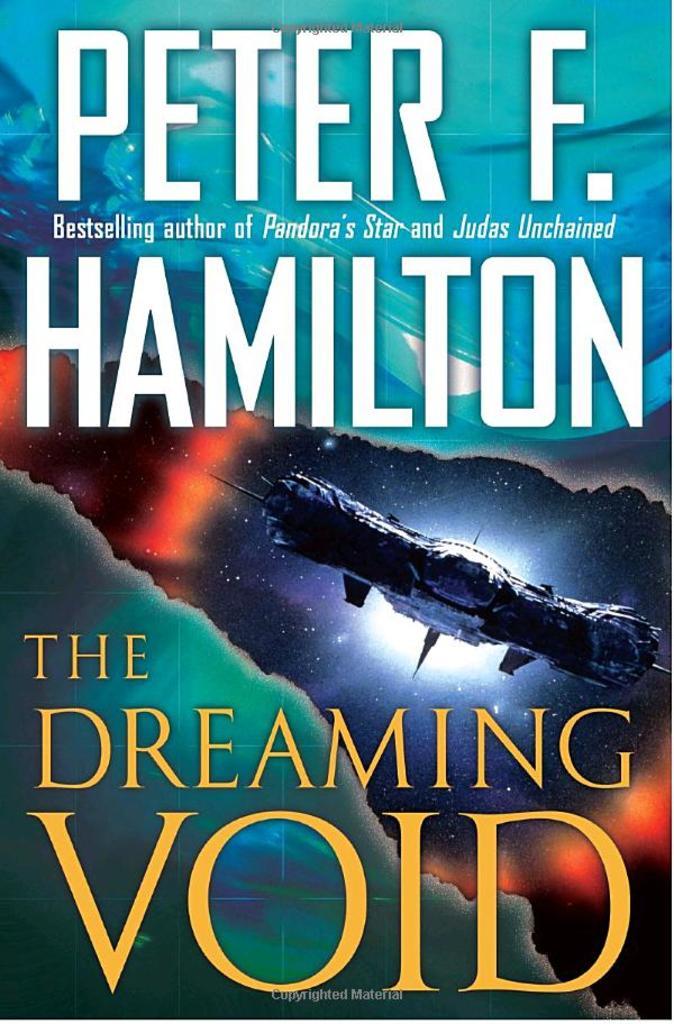What's the author's first name?
Give a very brief answer. Peter. What is the title of the book?
Your answer should be very brief. The dreaming void. 